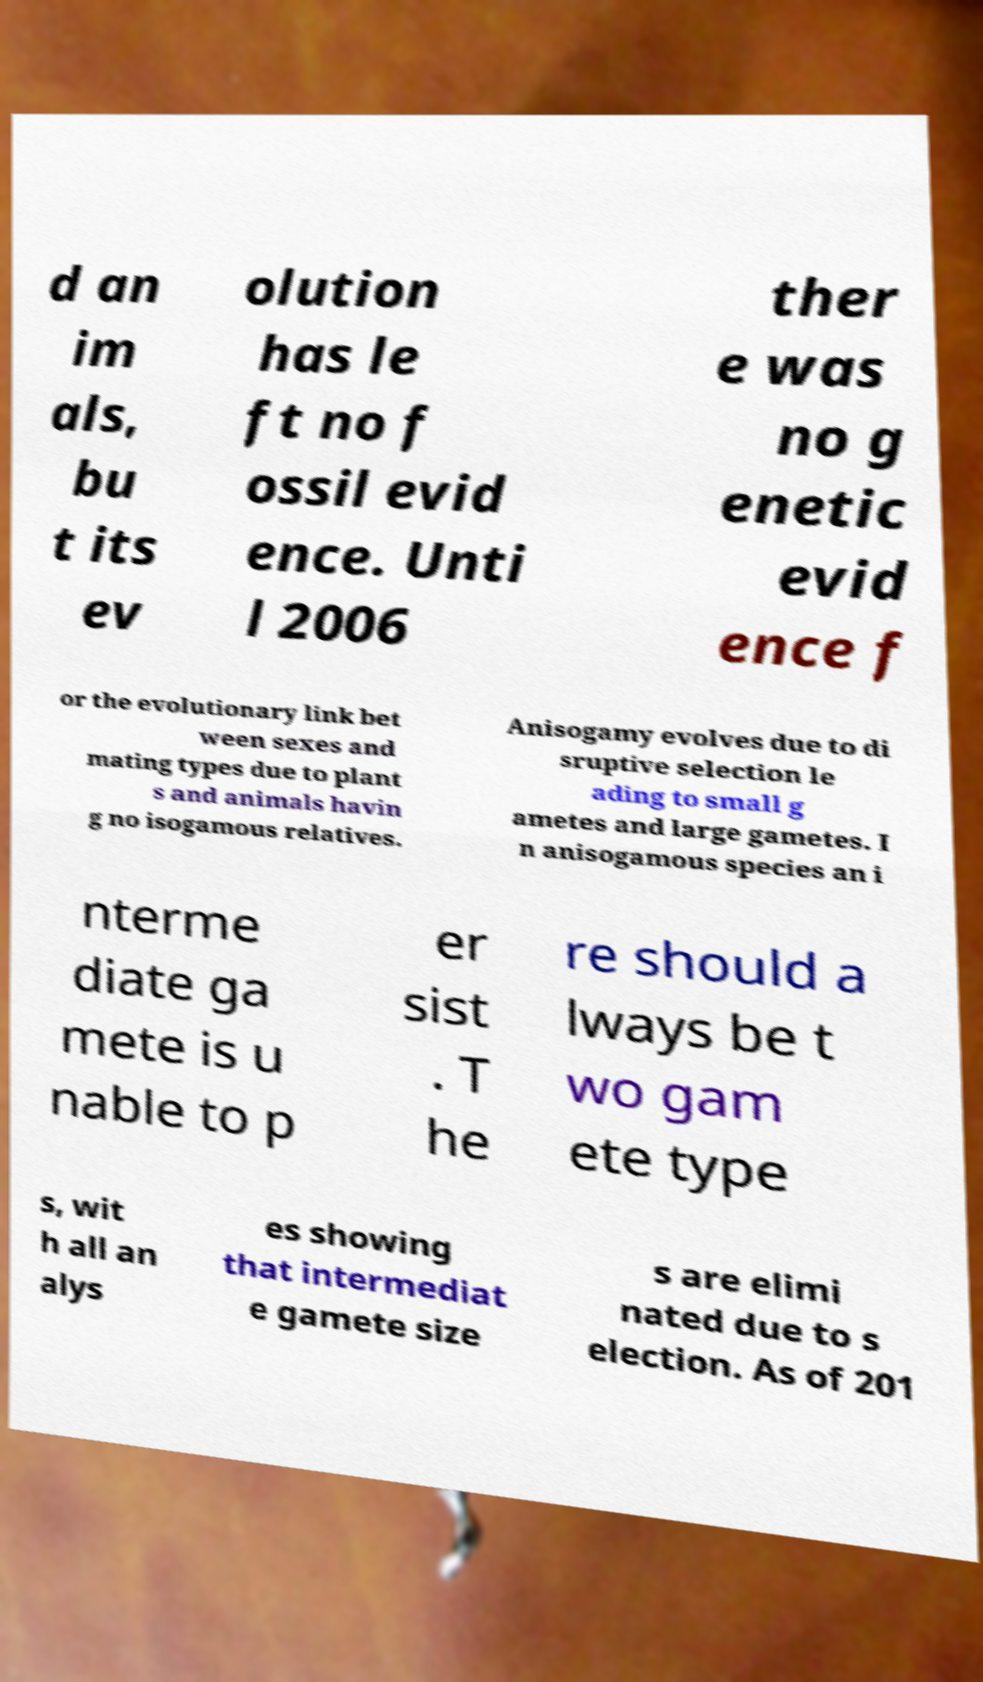I need the written content from this picture converted into text. Can you do that? d an im als, bu t its ev olution has le ft no f ossil evid ence. Unti l 2006 ther e was no g enetic evid ence f or the evolutionary link bet ween sexes and mating types due to plant s and animals havin g no isogamous relatives. Anisogamy evolves due to di sruptive selection le ading to small g ametes and large gametes. I n anisogamous species an i nterme diate ga mete is u nable to p er sist . T he re should a lways be t wo gam ete type s, wit h all an alys es showing that intermediat e gamete size s are elimi nated due to s election. As of 201 